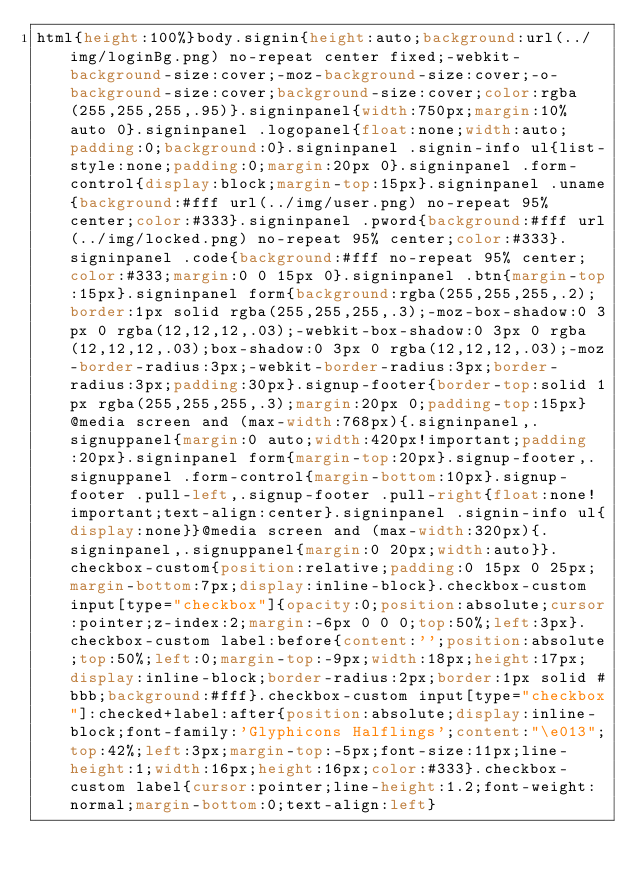<code> <loc_0><loc_0><loc_500><loc_500><_CSS_>html{height:100%}body.signin{height:auto;background:url(../img/loginBg.png) no-repeat center fixed;-webkit-background-size:cover;-moz-background-size:cover;-o-background-size:cover;background-size:cover;color:rgba(255,255,255,.95)}.signinpanel{width:750px;margin:10% auto 0}.signinpanel .logopanel{float:none;width:auto;padding:0;background:0}.signinpanel .signin-info ul{list-style:none;padding:0;margin:20px 0}.signinpanel .form-control{display:block;margin-top:15px}.signinpanel .uname{background:#fff url(../img/user.png) no-repeat 95% center;color:#333}.signinpanel .pword{background:#fff url(../img/locked.png) no-repeat 95% center;color:#333}.signinpanel .code{background:#fff no-repeat 95% center;color:#333;margin:0 0 15px 0}.signinpanel .btn{margin-top:15px}.signinpanel form{background:rgba(255,255,255,.2);border:1px solid rgba(255,255,255,.3);-moz-box-shadow:0 3px 0 rgba(12,12,12,.03);-webkit-box-shadow:0 3px 0 rgba(12,12,12,.03);box-shadow:0 3px 0 rgba(12,12,12,.03);-moz-border-radius:3px;-webkit-border-radius:3px;border-radius:3px;padding:30px}.signup-footer{border-top:solid 1px rgba(255,255,255,.3);margin:20px 0;padding-top:15px}@media screen and (max-width:768px){.signinpanel,.signuppanel{margin:0 auto;width:420px!important;padding:20px}.signinpanel form{margin-top:20px}.signup-footer,.signuppanel .form-control{margin-bottom:10px}.signup-footer .pull-left,.signup-footer .pull-right{float:none!important;text-align:center}.signinpanel .signin-info ul{display:none}}@media screen and (max-width:320px){.signinpanel,.signuppanel{margin:0 20px;width:auto}}.checkbox-custom{position:relative;padding:0 15px 0 25px;margin-bottom:7px;display:inline-block}.checkbox-custom input[type="checkbox"]{opacity:0;position:absolute;cursor:pointer;z-index:2;margin:-6px 0 0 0;top:50%;left:3px}.checkbox-custom label:before{content:'';position:absolute;top:50%;left:0;margin-top:-9px;width:18px;height:17px;display:inline-block;border-radius:2px;border:1px solid #bbb;background:#fff}.checkbox-custom input[type="checkbox"]:checked+label:after{position:absolute;display:inline-block;font-family:'Glyphicons Halflings';content:"\e013";top:42%;left:3px;margin-top:-5px;font-size:11px;line-height:1;width:16px;height:16px;color:#333}.checkbox-custom label{cursor:pointer;line-height:1.2;font-weight:normal;margin-bottom:0;text-align:left}</code> 